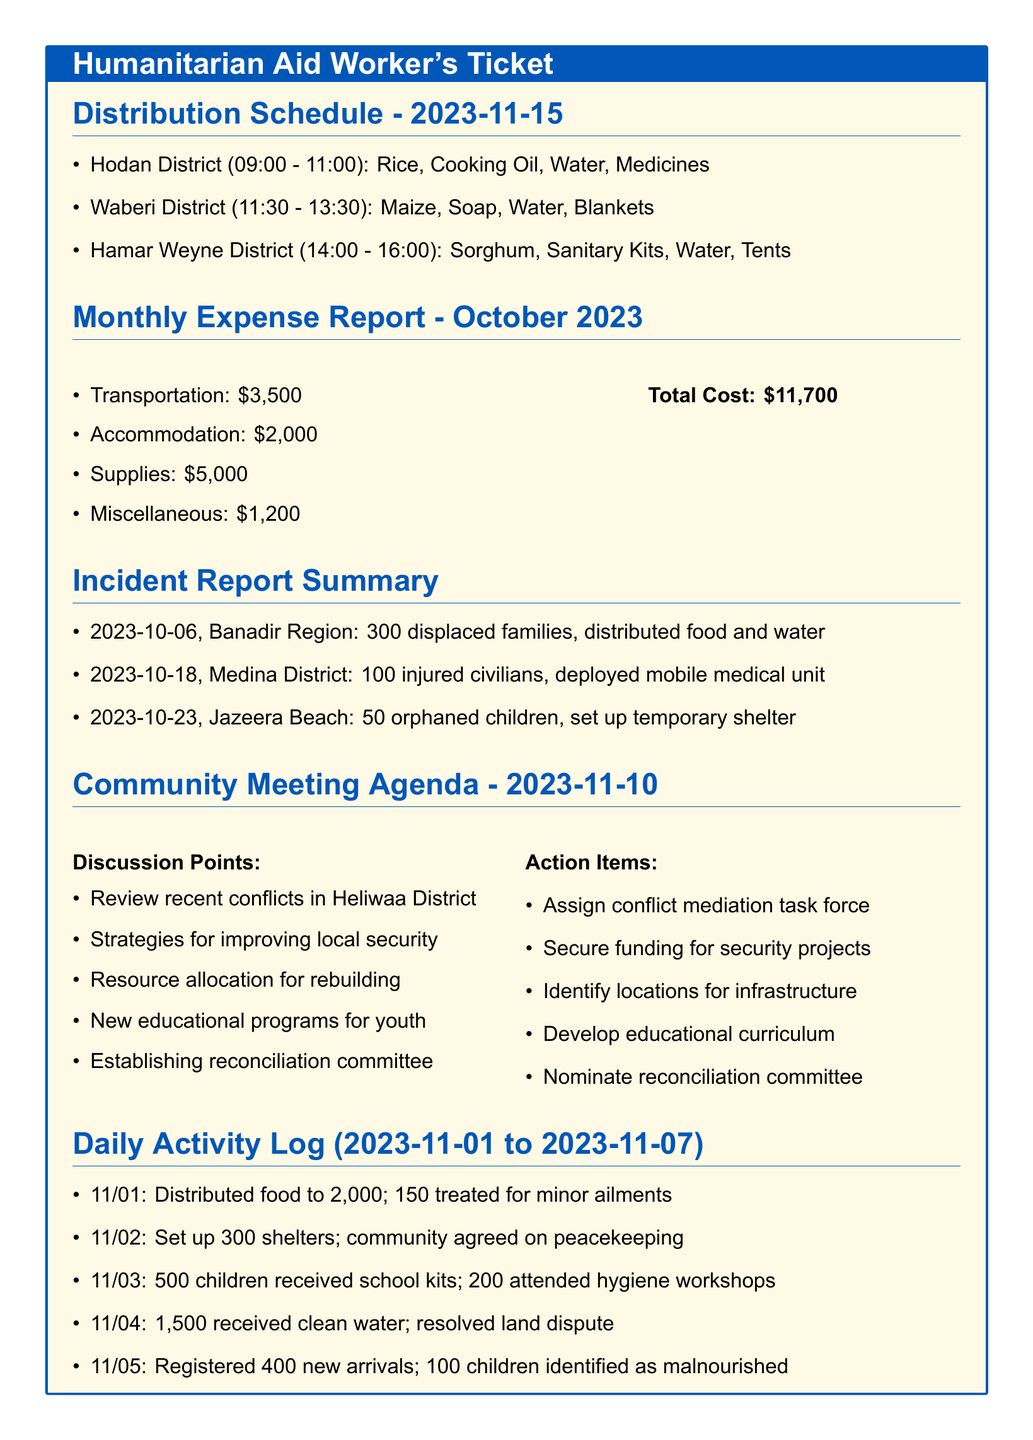What is the total cost of the monthly expenses? The total cost is calculated by summing up all the expenses listed in the Monthly Expense Report section.
Answer: $11,700 What items were distributed in Hodan District? The items distributed in Hodan District are listed in the Distribution Schedule and include rice, cooking oil, water, and medicines.
Answer: Rice, Cooking Oil, Water, Medicines How many families were displaced in Banadir Region? The document states that 300 families were displaced, as mentioned in the Incident Report Summary section.
Answer: 300 What date was the community meeting held? The community meeting agenda states that the meeting took place on 2023-11-10.
Answer: 2023-11-10 How many children received school kits on November 3rd? The Daily Activity Log indicates that 500 children received school kits on that date.
Answer: 500 What action item involves a task force? One of the action items listed in the Community Meeting Agenda mentions assigning a conflict mediation task force.
Answer: Conflict mediation task force Which district experienced the setup of temporary shelter for orphaned children? The Incident Report Summary states that temporary shelter was set up for 50 orphaned children at Jazeera Beach.
Answer: Jazeera Beach What is the time slot for distributions in Waberi District? The Distribution Schedule specifies that distributions in Waberi District occur from 11:30 to 13:30.
Answer: 11:30 - 13:30 How many shelters were set up on November 2nd? According to the Daily Activity Log, 300 shelters were set up on November 2nd.
Answer: 300 